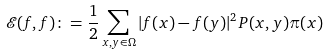Convert formula to latex. <formula><loc_0><loc_0><loc_500><loc_500>\mathcal { E } ( f , f ) \colon = \frac { 1 } { 2 } \sum _ { x , y \in \Omega } | f ( x ) - f ( y ) | ^ { 2 } P ( x , y ) \pi ( x )</formula> 